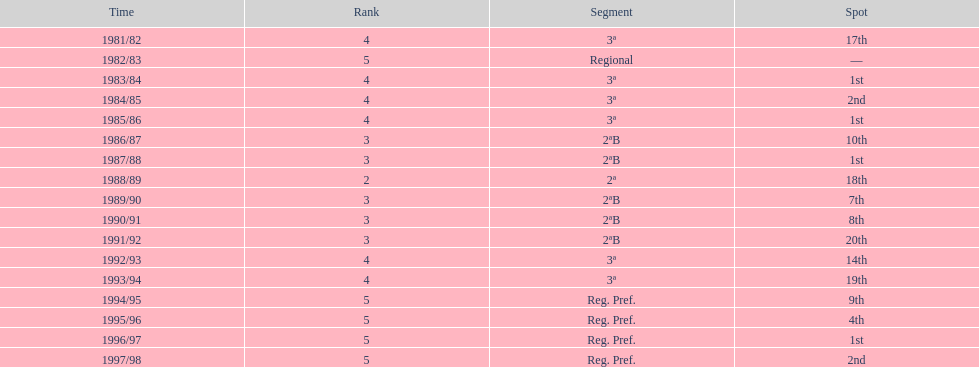Can you parse all the data within this table? {'header': ['Time', 'Rank', 'Segment', 'Spot'], 'rows': [['1981/82', '4', '3ª', '17th'], ['1982/83', '5', 'Regional', '—'], ['1983/84', '4', '3ª', '1st'], ['1984/85', '4', '3ª', '2nd'], ['1985/86', '4', '3ª', '1st'], ['1986/87', '3', '2ªB', '10th'], ['1987/88', '3', '2ªB', '1st'], ['1988/89', '2', '2ª', '18th'], ['1989/90', '3', '2ªB', '7th'], ['1990/91', '3', '2ªB', '8th'], ['1991/92', '3', '2ªB', '20th'], ['1992/93', '4', '3ª', '14th'], ['1993/94', '4', '3ª', '19th'], ['1994/95', '5', 'Reg. Pref.', '9th'], ['1995/96', '5', 'Reg. Pref.', '4th'], ['1996/97', '5', 'Reg. Pref.', '1st'], ['1997/98', '5', 'Reg. Pref.', '2nd']]} In which year did the team have its worst season? 1991/92. 